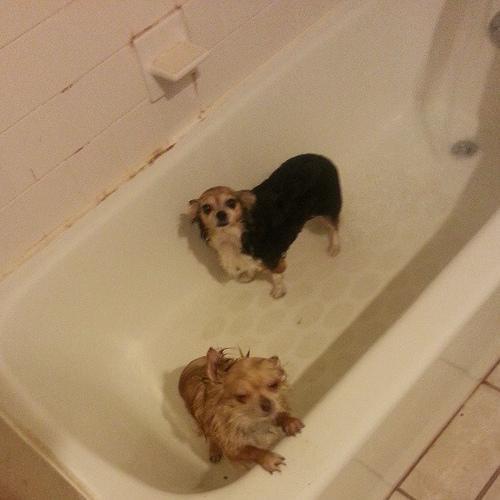How many dogs?
Give a very brief answer. 2. 